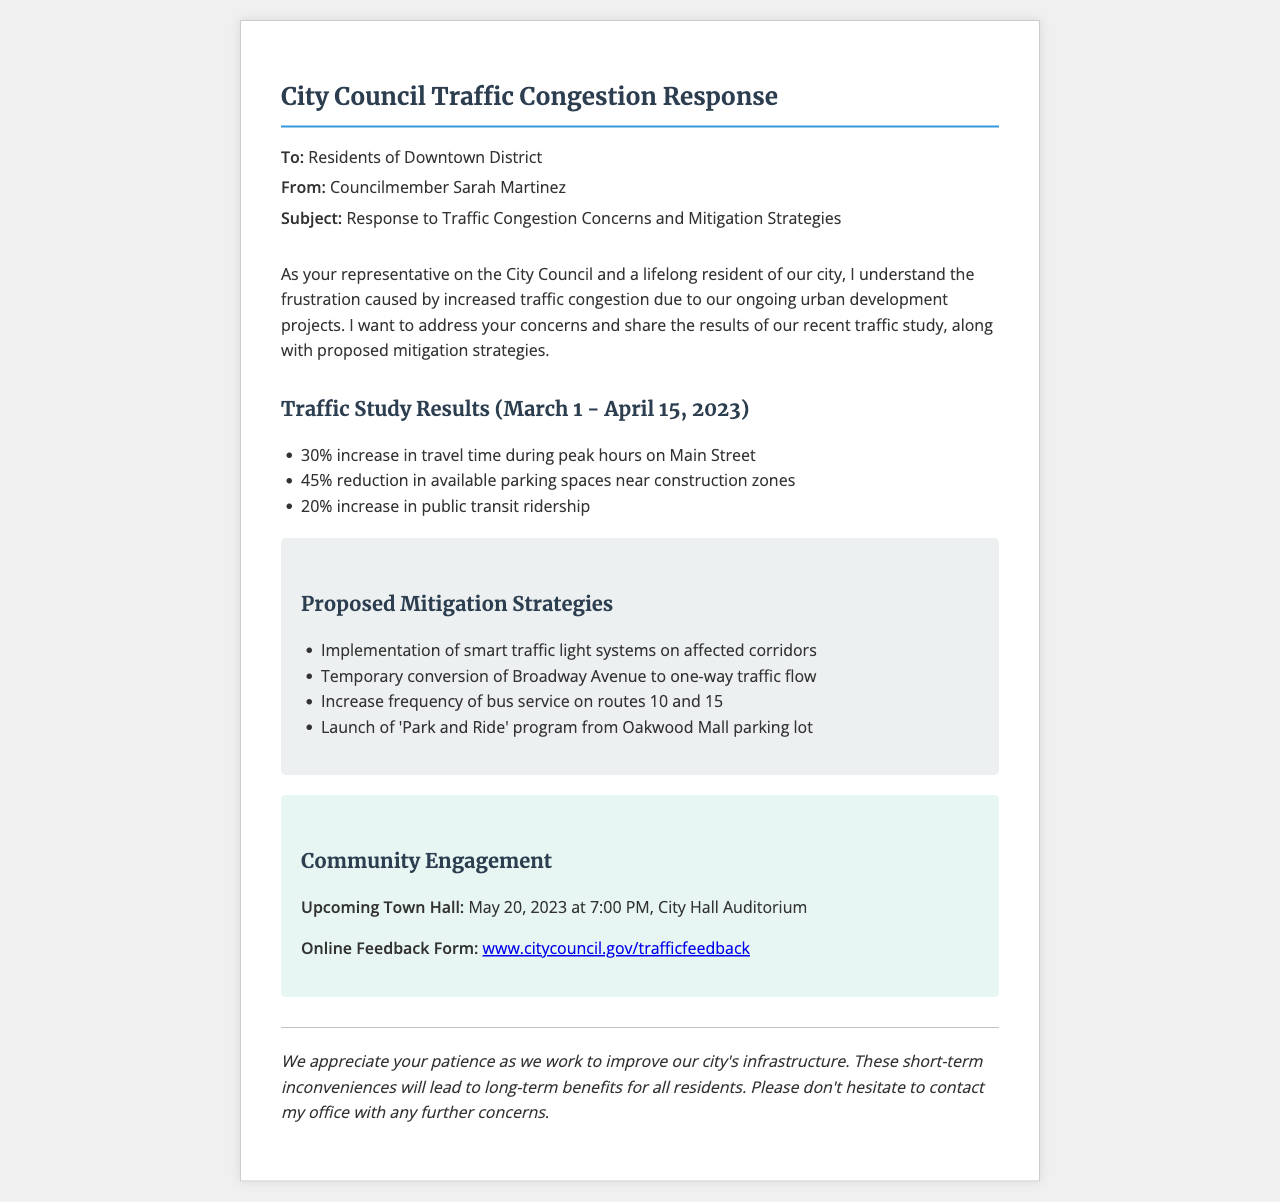What percentage increase in travel time was observed during peak hours on Main Street? The document states that there is a 30% increase in travel time during peak hours on Main Street, which is a specific piece of information retrieved from the traffic study results.
Answer: 30% What is the reduction in available parking spaces near construction zones? According to the traffic study results, there is a 45% reduction in available parking spaces near construction zones, indicating the impact of construction on parking.
Answer: 45% How many routes will have increased bus service frequency? The document mentions that the frequency of bus service will increase on routes 10 and 15, which requires understanding the approach toward mitigating traffic issues by enhancing public transit.
Answer: 2 When is the upcoming town hall meeting? The document specifies the date and time of the upcoming town hall meeting as May 20, 2023, at 7:00 PM, providing a clear detail about community engagement.
Answer: May 20, 2023 What mitigation strategy involves changes to Broadway Avenue? The document lists the temporary conversion of Broadway Avenue to one-way traffic flow as one of the proposed mitigation strategies to address traffic congestion.
Answer: One-way traffic flow What is the link for the online feedback form? The document provides a specific web address for the online feedback form, which allows residents to participate in providing input regarding traffic issues.
Answer: www.citycouncil.gov/trafficfeedback What is the main subject of the fax? The fax's subject is explicitly stated as "Response to Traffic Congestion Concerns and Mitigation Strategies," highlighting the focus of the communication.
Answer: Response to Traffic Congestion Concerns and Mitigation Strategies What percentage increase in public transit ridership was reported? The traffic study results indicate a 20% increase in public transit ridership, which reflects changes in transportation behavior due to construction activities.
Answer: 20% What does the document suggest will lead to long-term benefits for residents? It suggests that the short-term inconveniences due to construction will lead to long-term benefits for all residents, emphasizing the positive outcomes intended from the urban development projects.
Answer: Long-term benefits 